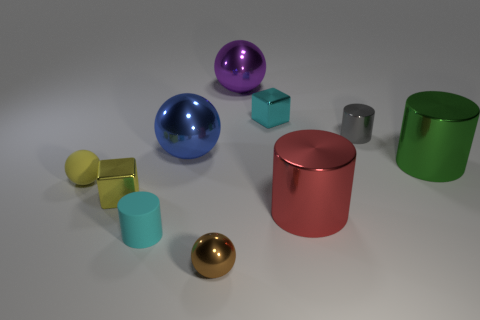Subtract 1 cylinders. How many cylinders are left? 3 Subtract all cylinders. How many objects are left? 6 Subtract all small brown shiny objects. Subtract all small yellow spheres. How many objects are left? 8 Add 3 green metallic cylinders. How many green metallic cylinders are left? 4 Add 2 brown metallic balls. How many brown metallic balls exist? 3 Subtract 1 brown balls. How many objects are left? 9 